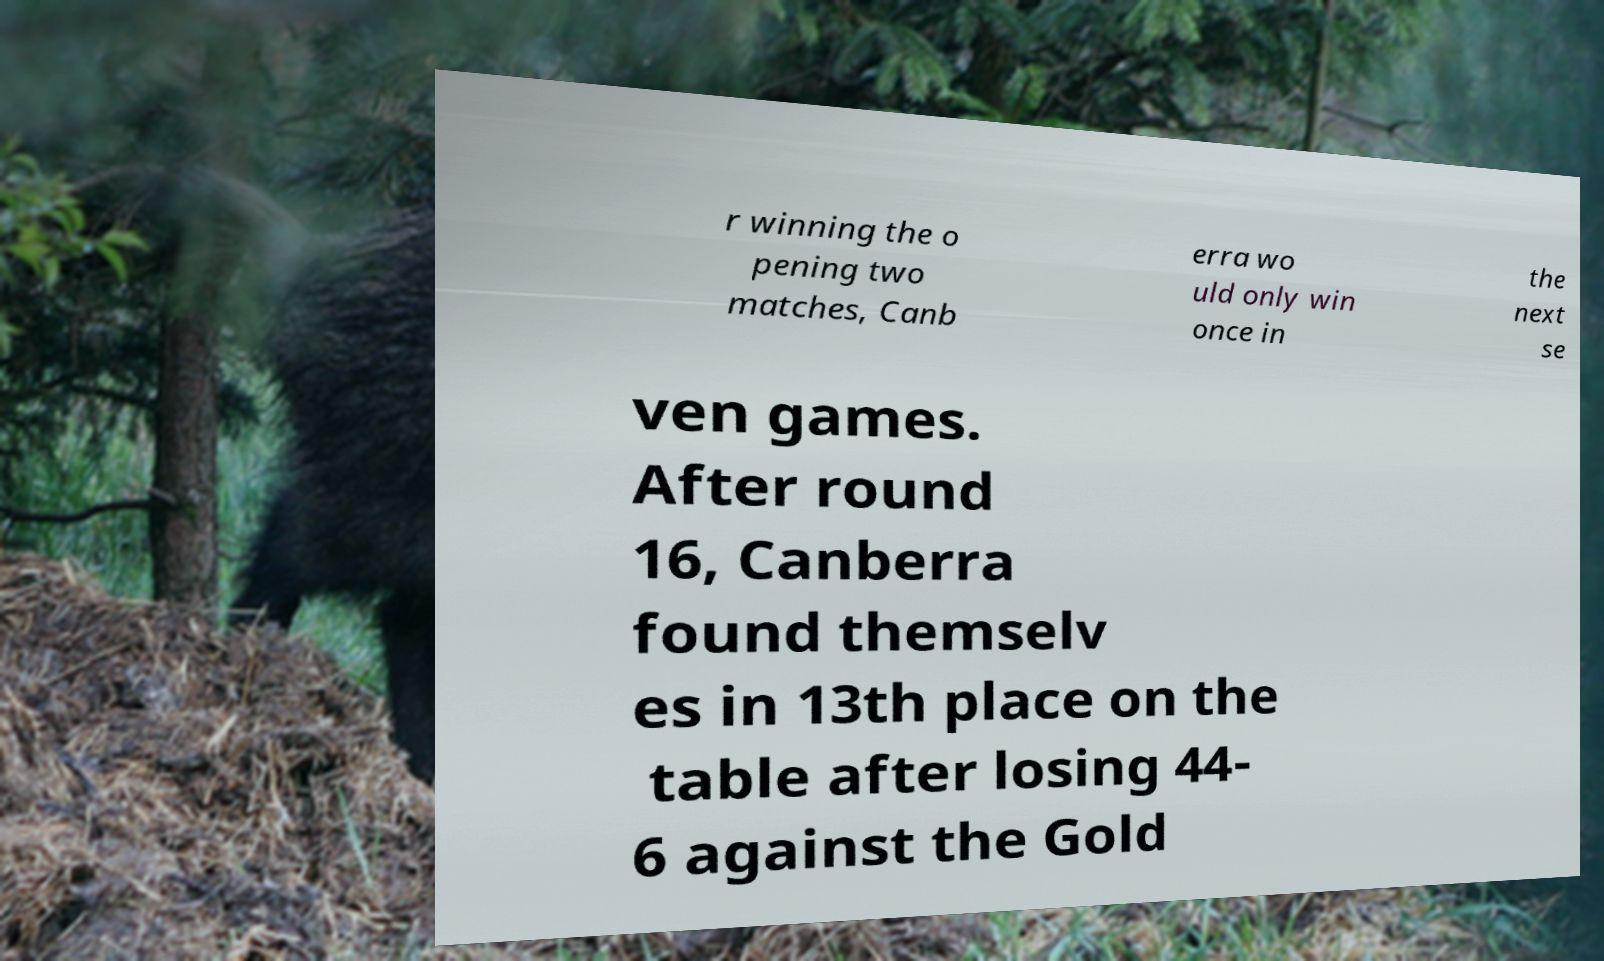Could you extract and type out the text from this image? r winning the o pening two matches, Canb erra wo uld only win once in the next se ven games. After round 16, Canberra found themselv es in 13th place on the table after losing 44- 6 against the Gold 